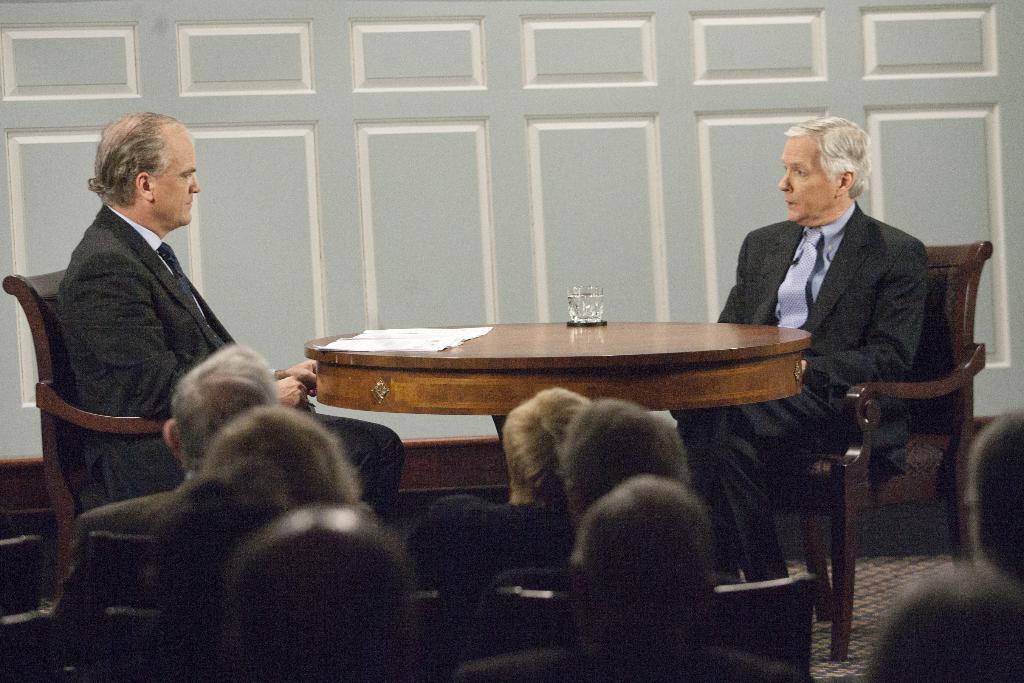How would you summarize this image in a sentence or two? Here we can see a person is sitting on the chair, and in front here is the table and glass on it, and here the group of people are sitting. 